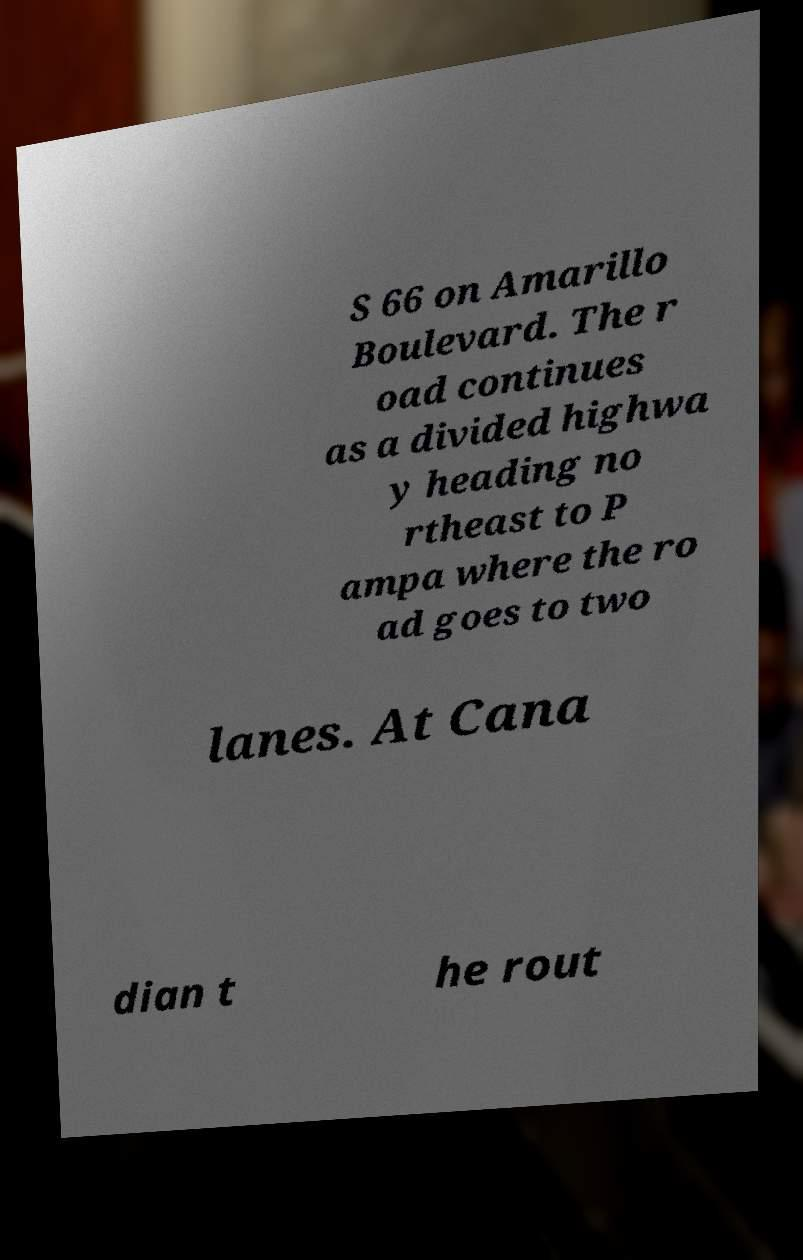I need the written content from this picture converted into text. Can you do that? S 66 on Amarillo Boulevard. The r oad continues as a divided highwa y heading no rtheast to P ampa where the ro ad goes to two lanes. At Cana dian t he rout 